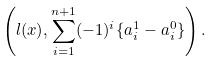Convert formula to latex. <formula><loc_0><loc_0><loc_500><loc_500>\left ( l ( x ) , \sum _ { i = 1 } ^ { n + 1 } ( - 1 ) ^ { i } \{ a ^ { 1 } _ { i } - a ^ { 0 } _ { i } \} \right ) .</formula> 